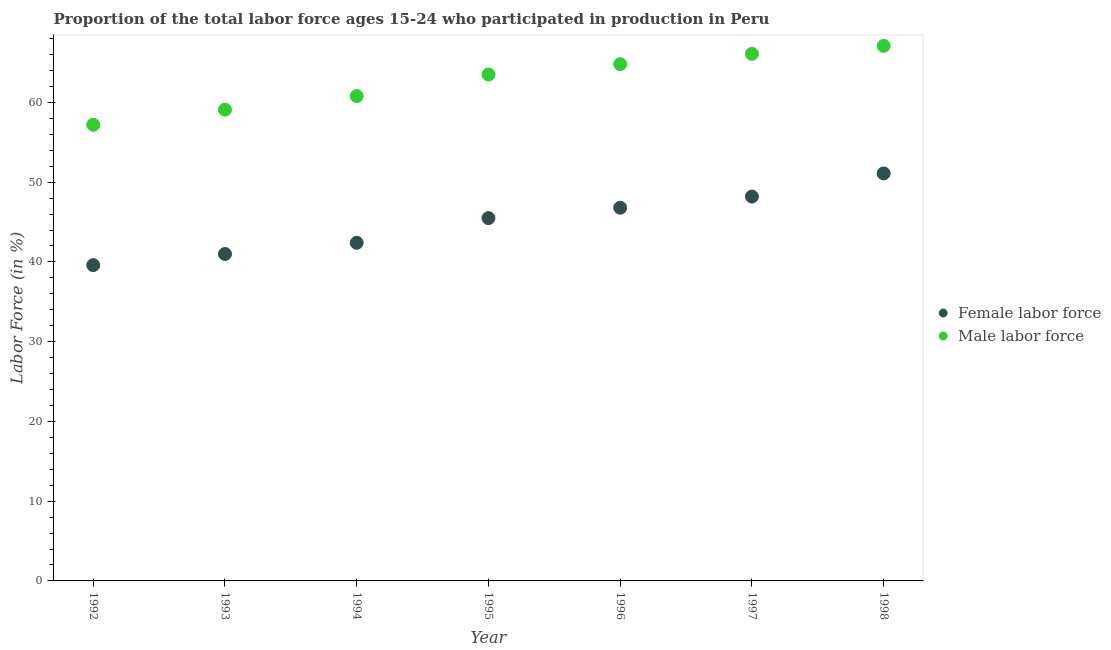How many different coloured dotlines are there?
Give a very brief answer. 2. Is the number of dotlines equal to the number of legend labels?
Your response must be concise. Yes. What is the percentage of male labour force in 1993?
Ensure brevity in your answer.  59.1. Across all years, what is the maximum percentage of male labour force?
Keep it short and to the point. 67.1. Across all years, what is the minimum percentage of male labour force?
Keep it short and to the point. 57.2. In which year was the percentage of male labour force maximum?
Your response must be concise. 1998. What is the total percentage of female labor force in the graph?
Offer a very short reply. 314.6. What is the difference between the percentage of female labor force in 1992 and that in 1994?
Offer a terse response. -2.8. What is the difference between the percentage of female labor force in 1992 and the percentage of male labour force in 1995?
Offer a terse response. -23.9. What is the average percentage of female labor force per year?
Keep it short and to the point. 44.94. In the year 1993, what is the difference between the percentage of male labour force and percentage of female labor force?
Offer a very short reply. 18.1. What is the ratio of the percentage of male labour force in 1994 to that in 1998?
Offer a terse response. 0.91. Is the difference between the percentage of male labour force in 1992 and 1998 greater than the difference between the percentage of female labor force in 1992 and 1998?
Offer a very short reply. Yes. What is the difference between the highest and the second highest percentage of male labour force?
Give a very brief answer. 1. What is the difference between the highest and the lowest percentage of male labour force?
Give a very brief answer. 9.9. Is the sum of the percentage of female labor force in 1992 and 1995 greater than the maximum percentage of male labour force across all years?
Give a very brief answer. Yes. Is the percentage of female labor force strictly less than the percentage of male labour force over the years?
Provide a short and direct response. Yes. How many years are there in the graph?
Offer a terse response. 7. Does the graph contain any zero values?
Your answer should be very brief. No. Does the graph contain grids?
Your answer should be very brief. No. How are the legend labels stacked?
Make the answer very short. Vertical. What is the title of the graph?
Give a very brief answer. Proportion of the total labor force ages 15-24 who participated in production in Peru. What is the label or title of the X-axis?
Your response must be concise. Year. What is the label or title of the Y-axis?
Your answer should be very brief. Labor Force (in %). What is the Labor Force (in %) in Female labor force in 1992?
Your response must be concise. 39.6. What is the Labor Force (in %) in Male labor force in 1992?
Your answer should be very brief. 57.2. What is the Labor Force (in %) in Female labor force in 1993?
Ensure brevity in your answer.  41. What is the Labor Force (in %) of Male labor force in 1993?
Ensure brevity in your answer.  59.1. What is the Labor Force (in %) of Female labor force in 1994?
Provide a short and direct response. 42.4. What is the Labor Force (in %) of Male labor force in 1994?
Provide a succinct answer. 60.8. What is the Labor Force (in %) in Female labor force in 1995?
Your response must be concise. 45.5. What is the Labor Force (in %) of Male labor force in 1995?
Provide a short and direct response. 63.5. What is the Labor Force (in %) in Female labor force in 1996?
Provide a succinct answer. 46.8. What is the Labor Force (in %) of Male labor force in 1996?
Provide a short and direct response. 64.8. What is the Labor Force (in %) of Female labor force in 1997?
Ensure brevity in your answer.  48.2. What is the Labor Force (in %) in Male labor force in 1997?
Give a very brief answer. 66.1. What is the Labor Force (in %) in Female labor force in 1998?
Your response must be concise. 51.1. What is the Labor Force (in %) of Male labor force in 1998?
Provide a succinct answer. 67.1. Across all years, what is the maximum Labor Force (in %) in Female labor force?
Provide a short and direct response. 51.1. Across all years, what is the maximum Labor Force (in %) of Male labor force?
Offer a terse response. 67.1. Across all years, what is the minimum Labor Force (in %) of Female labor force?
Ensure brevity in your answer.  39.6. Across all years, what is the minimum Labor Force (in %) of Male labor force?
Give a very brief answer. 57.2. What is the total Labor Force (in %) of Female labor force in the graph?
Your response must be concise. 314.6. What is the total Labor Force (in %) of Male labor force in the graph?
Ensure brevity in your answer.  438.6. What is the difference between the Labor Force (in %) in Male labor force in 1992 and that in 1993?
Your answer should be very brief. -1.9. What is the difference between the Labor Force (in %) in Female labor force in 1992 and that in 1994?
Offer a terse response. -2.8. What is the difference between the Labor Force (in %) of Male labor force in 1992 and that in 1994?
Offer a very short reply. -3.6. What is the difference between the Labor Force (in %) in Female labor force in 1992 and that in 1995?
Keep it short and to the point. -5.9. What is the difference between the Labor Force (in %) in Male labor force in 1992 and that in 1995?
Your response must be concise. -6.3. What is the difference between the Labor Force (in %) in Female labor force in 1992 and that in 1996?
Your answer should be very brief. -7.2. What is the difference between the Labor Force (in %) in Male labor force in 1992 and that in 1997?
Ensure brevity in your answer.  -8.9. What is the difference between the Labor Force (in %) of Female labor force in 1992 and that in 1998?
Your answer should be very brief. -11.5. What is the difference between the Labor Force (in %) of Female labor force in 1993 and that in 1995?
Offer a very short reply. -4.5. What is the difference between the Labor Force (in %) of Male labor force in 1993 and that in 1998?
Your answer should be compact. -8. What is the difference between the Labor Force (in %) in Female labor force in 1994 and that in 1995?
Make the answer very short. -3.1. What is the difference between the Labor Force (in %) of Male labor force in 1994 and that in 1996?
Your response must be concise. -4. What is the difference between the Labor Force (in %) of Male labor force in 1994 and that in 1997?
Give a very brief answer. -5.3. What is the difference between the Labor Force (in %) of Male labor force in 1994 and that in 1998?
Make the answer very short. -6.3. What is the difference between the Labor Force (in %) of Female labor force in 1995 and that in 1996?
Your response must be concise. -1.3. What is the difference between the Labor Force (in %) of Male labor force in 1995 and that in 1997?
Your response must be concise. -2.6. What is the difference between the Labor Force (in %) of Female labor force in 1995 and that in 1998?
Offer a terse response. -5.6. What is the difference between the Labor Force (in %) in Female labor force in 1996 and that in 1998?
Provide a short and direct response. -4.3. What is the difference between the Labor Force (in %) of Male labor force in 1997 and that in 1998?
Your response must be concise. -1. What is the difference between the Labor Force (in %) in Female labor force in 1992 and the Labor Force (in %) in Male labor force in 1993?
Your answer should be compact. -19.5. What is the difference between the Labor Force (in %) in Female labor force in 1992 and the Labor Force (in %) in Male labor force in 1994?
Your answer should be compact. -21.2. What is the difference between the Labor Force (in %) of Female labor force in 1992 and the Labor Force (in %) of Male labor force in 1995?
Make the answer very short. -23.9. What is the difference between the Labor Force (in %) in Female labor force in 1992 and the Labor Force (in %) in Male labor force in 1996?
Your response must be concise. -25.2. What is the difference between the Labor Force (in %) in Female labor force in 1992 and the Labor Force (in %) in Male labor force in 1997?
Your response must be concise. -26.5. What is the difference between the Labor Force (in %) in Female labor force in 1992 and the Labor Force (in %) in Male labor force in 1998?
Ensure brevity in your answer.  -27.5. What is the difference between the Labor Force (in %) of Female labor force in 1993 and the Labor Force (in %) of Male labor force in 1994?
Provide a short and direct response. -19.8. What is the difference between the Labor Force (in %) of Female labor force in 1993 and the Labor Force (in %) of Male labor force in 1995?
Your answer should be very brief. -22.5. What is the difference between the Labor Force (in %) of Female labor force in 1993 and the Labor Force (in %) of Male labor force in 1996?
Offer a very short reply. -23.8. What is the difference between the Labor Force (in %) in Female labor force in 1993 and the Labor Force (in %) in Male labor force in 1997?
Your answer should be very brief. -25.1. What is the difference between the Labor Force (in %) in Female labor force in 1993 and the Labor Force (in %) in Male labor force in 1998?
Provide a short and direct response. -26.1. What is the difference between the Labor Force (in %) of Female labor force in 1994 and the Labor Force (in %) of Male labor force in 1995?
Offer a very short reply. -21.1. What is the difference between the Labor Force (in %) of Female labor force in 1994 and the Labor Force (in %) of Male labor force in 1996?
Offer a terse response. -22.4. What is the difference between the Labor Force (in %) of Female labor force in 1994 and the Labor Force (in %) of Male labor force in 1997?
Your answer should be very brief. -23.7. What is the difference between the Labor Force (in %) in Female labor force in 1994 and the Labor Force (in %) in Male labor force in 1998?
Your answer should be very brief. -24.7. What is the difference between the Labor Force (in %) of Female labor force in 1995 and the Labor Force (in %) of Male labor force in 1996?
Provide a short and direct response. -19.3. What is the difference between the Labor Force (in %) in Female labor force in 1995 and the Labor Force (in %) in Male labor force in 1997?
Your answer should be very brief. -20.6. What is the difference between the Labor Force (in %) in Female labor force in 1995 and the Labor Force (in %) in Male labor force in 1998?
Offer a terse response. -21.6. What is the difference between the Labor Force (in %) in Female labor force in 1996 and the Labor Force (in %) in Male labor force in 1997?
Offer a very short reply. -19.3. What is the difference between the Labor Force (in %) in Female labor force in 1996 and the Labor Force (in %) in Male labor force in 1998?
Make the answer very short. -20.3. What is the difference between the Labor Force (in %) of Female labor force in 1997 and the Labor Force (in %) of Male labor force in 1998?
Your answer should be very brief. -18.9. What is the average Labor Force (in %) of Female labor force per year?
Keep it short and to the point. 44.94. What is the average Labor Force (in %) of Male labor force per year?
Provide a succinct answer. 62.66. In the year 1992, what is the difference between the Labor Force (in %) of Female labor force and Labor Force (in %) of Male labor force?
Your answer should be compact. -17.6. In the year 1993, what is the difference between the Labor Force (in %) of Female labor force and Labor Force (in %) of Male labor force?
Provide a succinct answer. -18.1. In the year 1994, what is the difference between the Labor Force (in %) of Female labor force and Labor Force (in %) of Male labor force?
Offer a very short reply. -18.4. In the year 1997, what is the difference between the Labor Force (in %) of Female labor force and Labor Force (in %) of Male labor force?
Keep it short and to the point. -17.9. In the year 1998, what is the difference between the Labor Force (in %) in Female labor force and Labor Force (in %) in Male labor force?
Your answer should be very brief. -16. What is the ratio of the Labor Force (in %) in Female labor force in 1992 to that in 1993?
Keep it short and to the point. 0.97. What is the ratio of the Labor Force (in %) in Male labor force in 1992 to that in 1993?
Make the answer very short. 0.97. What is the ratio of the Labor Force (in %) of Female labor force in 1992 to that in 1994?
Ensure brevity in your answer.  0.93. What is the ratio of the Labor Force (in %) of Male labor force in 1992 to that in 1994?
Your answer should be compact. 0.94. What is the ratio of the Labor Force (in %) in Female labor force in 1992 to that in 1995?
Offer a terse response. 0.87. What is the ratio of the Labor Force (in %) in Male labor force in 1992 to that in 1995?
Provide a short and direct response. 0.9. What is the ratio of the Labor Force (in %) of Female labor force in 1992 to that in 1996?
Provide a short and direct response. 0.85. What is the ratio of the Labor Force (in %) in Male labor force in 1992 to that in 1996?
Offer a very short reply. 0.88. What is the ratio of the Labor Force (in %) of Female labor force in 1992 to that in 1997?
Your answer should be compact. 0.82. What is the ratio of the Labor Force (in %) of Male labor force in 1992 to that in 1997?
Provide a short and direct response. 0.87. What is the ratio of the Labor Force (in %) of Female labor force in 1992 to that in 1998?
Offer a very short reply. 0.78. What is the ratio of the Labor Force (in %) of Male labor force in 1992 to that in 1998?
Keep it short and to the point. 0.85. What is the ratio of the Labor Force (in %) in Female labor force in 1993 to that in 1994?
Your response must be concise. 0.97. What is the ratio of the Labor Force (in %) of Female labor force in 1993 to that in 1995?
Keep it short and to the point. 0.9. What is the ratio of the Labor Force (in %) in Male labor force in 1993 to that in 1995?
Keep it short and to the point. 0.93. What is the ratio of the Labor Force (in %) of Female labor force in 1993 to that in 1996?
Keep it short and to the point. 0.88. What is the ratio of the Labor Force (in %) of Male labor force in 1993 to that in 1996?
Your response must be concise. 0.91. What is the ratio of the Labor Force (in %) in Female labor force in 1993 to that in 1997?
Provide a short and direct response. 0.85. What is the ratio of the Labor Force (in %) of Male labor force in 1993 to that in 1997?
Offer a very short reply. 0.89. What is the ratio of the Labor Force (in %) of Female labor force in 1993 to that in 1998?
Ensure brevity in your answer.  0.8. What is the ratio of the Labor Force (in %) in Male labor force in 1993 to that in 1998?
Make the answer very short. 0.88. What is the ratio of the Labor Force (in %) in Female labor force in 1994 to that in 1995?
Offer a terse response. 0.93. What is the ratio of the Labor Force (in %) of Male labor force in 1994 to that in 1995?
Give a very brief answer. 0.96. What is the ratio of the Labor Force (in %) of Female labor force in 1994 to that in 1996?
Your response must be concise. 0.91. What is the ratio of the Labor Force (in %) in Male labor force in 1994 to that in 1996?
Your response must be concise. 0.94. What is the ratio of the Labor Force (in %) of Female labor force in 1994 to that in 1997?
Make the answer very short. 0.88. What is the ratio of the Labor Force (in %) in Male labor force in 1994 to that in 1997?
Give a very brief answer. 0.92. What is the ratio of the Labor Force (in %) in Female labor force in 1994 to that in 1998?
Your answer should be very brief. 0.83. What is the ratio of the Labor Force (in %) in Male labor force in 1994 to that in 1998?
Your response must be concise. 0.91. What is the ratio of the Labor Force (in %) of Female labor force in 1995 to that in 1996?
Your response must be concise. 0.97. What is the ratio of the Labor Force (in %) of Male labor force in 1995 to that in 1996?
Your answer should be very brief. 0.98. What is the ratio of the Labor Force (in %) in Female labor force in 1995 to that in 1997?
Make the answer very short. 0.94. What is the ratio of the Labor Force (in %) in Male labor force in 1995 to that in 1997?
Offer a very short reply. 0.96. What is the ratio of the Labor Force (in %) in Female labor force in 1995 to that in 1998?
Keep it short and to the point. 0.89. What is the ratio of the Labor Force (in %) of Male labor force in 1995 to that in 1998?
Keep it short and to the point. 0.95. What is the ratio of the Labor Force (in %) of Female labor force in 1996 to that in 1997?
Offer a terse response. 0.97. What is the ratio of the Labor Force (in %) in Male labor force in 1996 to that in 1997?
Ensure brevity in your answer.  0.98. What is the ratio of the Labor Force (in %) in Female labor force in 1996 to that in 1998?
Provide a short and direct response. 0.92. What is the ratio of the Labor Force (in %) of Male labor force in 1996 to that in 1998?
Ensure brevity in your answer.  0.97. What is the ratio of the Labor Force (in %) of Female labor force in 1997 to that in 1998?
Your answer should be very brief. 0.94. What is the ratio of the Labor Force (in %) in Male labor force in 1997 to that in 1998?
Your response must be concise. 0.99. What is the difference between the highest and the lowest Labor Force (in %) in Female labor force?
Provide a succinct answer. 11.5. 